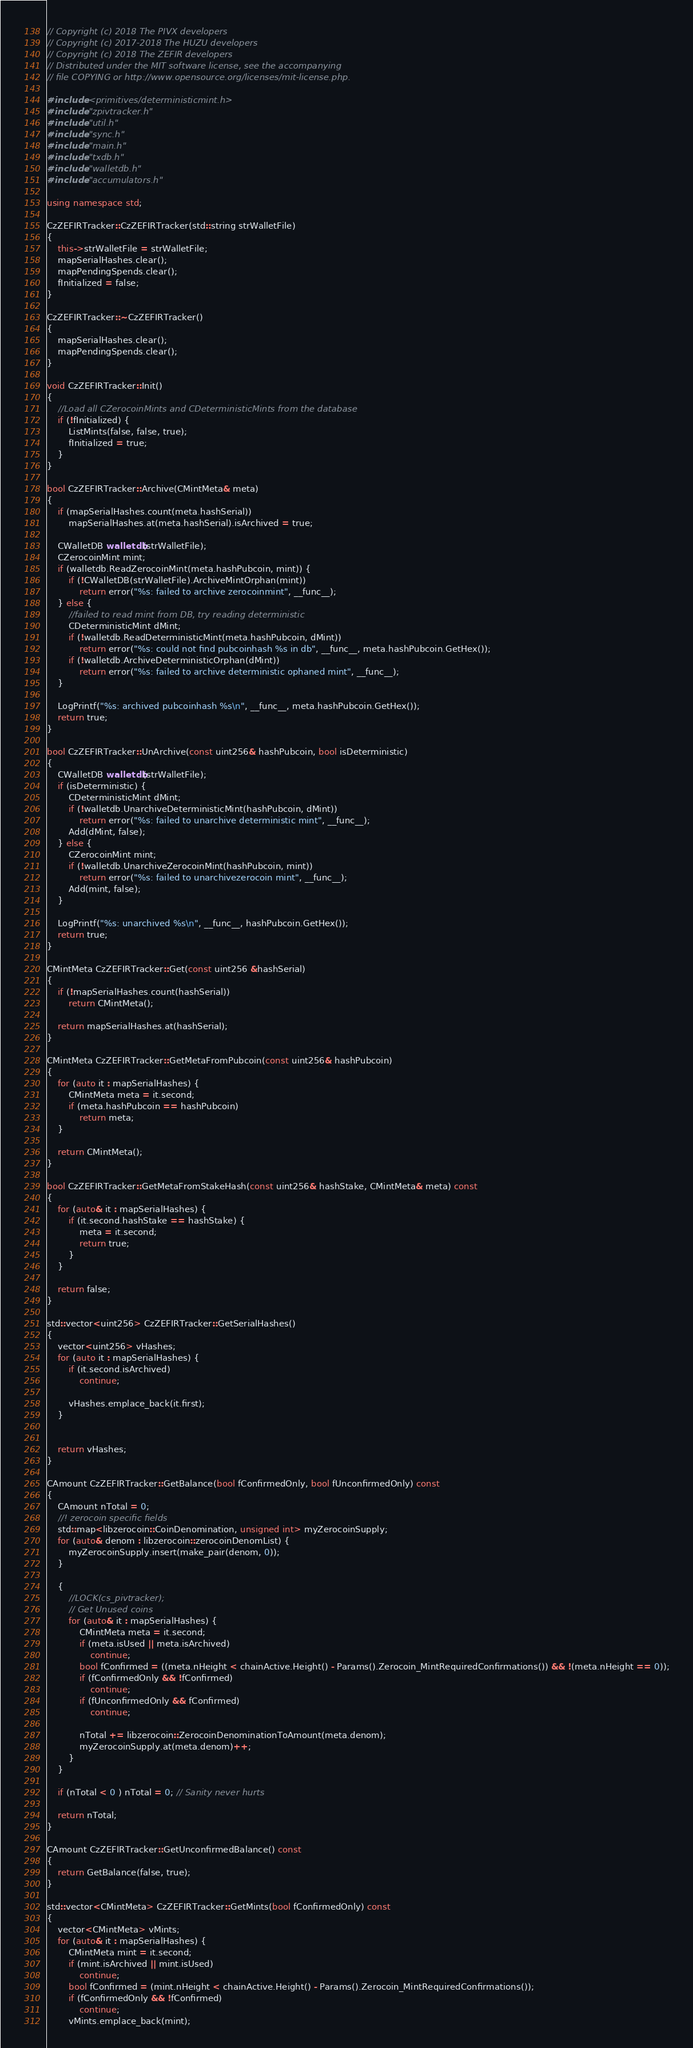<code> <loc_0><loc_0><loc_500><loc_500><_C++_>// Copyright (c) 2018 The PIVX developers
// Copyright (c) 2017-2018 The HUZU developers
// Copyright (c) 2018 The ZEFIR developers
// Distributed under the MIT software license, see the accompanying
// file COPYING or http://www.opensource.org/licenses/mit-license.php.

#include <primitives/deterministicmint.h>
#include "zpivtracker.h"
#include "util.h"
#include "sync.h"
#include "main.h"
#include "txdb.h"
#include "walletdb.h"
#include "accumulators.h"

using namespace std;

CzZEFIRTracker::CzZEFIRTracker(std::string strWalletFile)
{
    this->strWalletFile = strWalletFile;
    mapSerialHashes.clear();
    mapPendingSpends.clear();
    fInitialized = false;
}

CzZEFIRTracker::~CzZEFIRTracker()
{
    mapSerialHashes.clear();
    mapPendingSpends.clear();
}

void CzZEFIRTracker::Init()
{
    //Load all CZerocoinMints and CDeterministicMints from the database
    if (!fInitialized) {
        ListMints(false, false, true);
        fInitialized = true;
    }
}

bool CzZEFIRTracker::Archive(CMintMeta& meta)
{
    if (mapSerialHashes.count(meta.hashSerial))
        mapSerialHashes.at(meta.hashSerial).isArchived = true;

    CWalletDB walletdb(strWalletFile);
    CZerocoinMint mint;
    if (walletdb.ReadZerocoinMint(meta.hashPubcoin, mint)) {
        if (!CWalletDB(strWalletFile).ArchiveMintOrphan(mint))
            return error("%s: failed to archive zerocoinmint", __func__);
    } else {
        //failed to read mint from DB, try reading deterministic
        CDeterministicMint dMint;
        if (!walletdb.ReadDeterministicMint(meta.hashPubcoin, dMint))
            return error("%s: could not find pubcoinhash %s in db", __func__, meta.hashPubcoin.GetHex());
        if (!walletdb.ArchiveDeterministicOrphan(dMint))
            return error("%s: failed to archive deterministic ophaned mint", __func__);
    }

    LogPrintf("%s: archived pubcoinhash %s\n", __func__, meta.hashPubcoin.GetHex());
    return true;
}

bool CzZEFIRTracker::UnArchive(const uint256& hashPubcoin, bool isDeterministic)
{
    CWalletDB walletdb(strWalletFile);
    if (isDeterministic) {
        CDeterministicMint dMint;
        if (!walletdb.UnarchiveDeterministicMint(hashPubcoin, dMint))
            return error("%s: failed to unarchive deterministic mint", __func__);
        Add(dMint, false);
    } else {
        CZerocoinMint mint;
        if (!walletdb.UnarchiveZerocoinMint(hashPubcoin, mint))
            return error("%s: failed to unarchivezerocoin mint", __func__);
        Add(mint, false);
    }

    LogPrintf("%s: unarchived %s\n", __func__, hashPubcoin.GetHex());
    return true;
}

CMintMeta CzZEFIRTracker::Get(const uint256 &hashSerial)
{
    if (!mapSerialHashes.count(hashSerial))
        return CMintMeta();

    return mapSerialHashes.at(hashSerial);
}

CMintMeta CzZEFIRTracker::GetMetaFromPubcoin(const uint256& hashPubcoin)
{
    for (auto it : mapSerialHashes) {
        CMintMeta meta = it.second;
        if (meta.hashPubcoin == hashPubcoin)
            return meta;
    }

    return CMintMeta();
}

bool CzZEFIRTracker::GetMetaFromStakeHash(const uint256& hashStake, CMintMeta& meta) const
{
    for (auto& it : mapSerialHashes) {
        if (it.second.hashStake == hashStake) {
            meta = it.second;
            return true;
        }
    }

    return false;
}

std::vector<uint256> CzZEFIRTracker::GetSerialHashes()
{
    vector<uint256> vHashes;
    for (auto it : mapSerialHashes) {
        if (it.second.isArchived)
            continue;

        vHashes.emplace_back(it.first);
    }


    return vHashes;
}

CAmount CzZEFIRTracker::GetBalance(bool fConfirmedOnly, bool fUnconfirmedOnly) const
{
    CAmount nTotal = 0;
    //! zerocoin specific fields
    std::map<libzerocoin::CoinDenomination, unsigned int> myZerocoinSupply;
    for (auto& denom : libzerocoin::zerocoinDenomList) {
        myZerocoinSupply.insert(make_pair(denom, 0));
    }

    {
        //LOCK(cs_pivtracker);
        // Get Unused coins
        for (auto& it : mapSerialHashes) {
            CMintMeta meta = it.second;
            if (meta.isUsed || meta.isArchived)
                continue;
            bool fConfirmed = ((meta.nHeight < chainActive.Height() - Params().Zerocoin_MintRequiredConfirmations()) && !(meta.nHeight == 0));
            if (fConfirmedOnly && !fConfirmed)
                continue;
            if (fUnconfirmedOnly && fConfirmed)
                continue;

            nTotal += libzerocoin::ZerocoinDenominationToAmount(meta.denom);
            myZerocoinSupply.at(meta.denom)++;
        }
    }

    if (nTotal < 0 ) nTotal = 0; // Sanity never hurts

    return nTotal;
}

CAmount CzZEFIRTracker::GetUnconfirmedBalance() const
{
    return GetBalance(false, true);
}

std::vector<CMintMeta> CzZEFIRTracker::GetMints(bool fConfirmedOnly) const
{
    vector<CMintMeta> vMints;
    for (auto& it : mapSerialHashes) {
        CMintMeta mint = it.second;
        if (mint.isArchived || mint.isUsed)
            continue;
        bool fConfirmed = (mint.nHeight < chainActive.Height() - Params().Zerocoin_MintRequiredConfirmations());
        if (fConfirmedOnly && !fConfirmed)
            continue;
        vMints.emplace_back(mint);</code> 